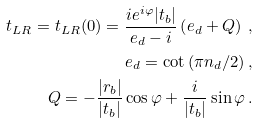<formula> <loc_0><loc_0><loc_500><loc_500>t _ { L R } = t _ { L R } ( 0 ) = \frac { i e ^ { i \varphi } | t _ { b } | } { e _ { d } - i } \left ( e _ { d } + Q \right ) \, , \\ e _ { d } = \cot { ( \pi n _ { d } / 2 ) } \, , \\ Q = - \frac { | r _ { b } | } { | t _ { b } | } \cos { \varphi } + \frac { i } { | t _ { b } | } \sin { \varphi } \, .</formula> 